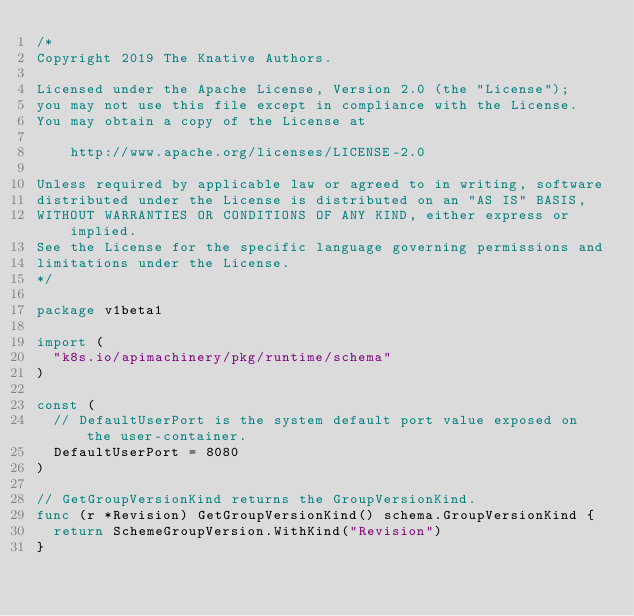Convert code to text. <code><loc_0><loc_0><loc_500><loc_500><_Go_>/*
Copyright 2019 The Knative Authors.

Licensed under the Apache License, Version 2.0 (the "License");
you may not use this file except in compliance with the License.
You may obtain a copy of the License at

    http://www.apache.org/licenses/LICENSE-2.0

Unless required by applicable law or agreed to in writing, software
distributed under the License is distributed on an "AS IS" BASIS,
WITHOUT WARRANTIES OR CONDITIONS OF ANY KIND, either express or implied.
See the License for the specific language governing permissions and
limitations under the License.
*/

package v1beta1

import (
	"k8s.io/apimachinery/pkg/runtime/schema"
)

const (
	// DefaultUserPort is the system default port value exposed on the user-container.
	DefaultUserPort = 8080
)

// GetGroupVersionKind returns the GroupVersionKind.
func (r *Revision) GetGroupVersionKind() schema.GroupVersionKind {
	return SchemeGroupVersion.WithKind("Revision")
}
</code> 